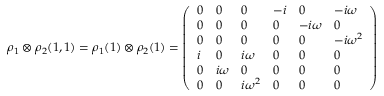Convert formula to latex. <formula><loc_0><loc_0><loc_500><loc_500>\rho _ { 1 } \otimes \rho _ { 2 } ( 1 , 1 ) = \rho _ { 1 } ( 1 ) \otimes \rho _ { 2 } ( 1 ) = { \left ( \begin{array} { l l l l l l } { 0 } & { 0 } & { 0 } & { - i } & { 0 } & { - i \omega } \\ { 0 } & { 0 } & { 0 } & { 0 } & { - i \omega } & { 0 } \\ { 0 } & { 0 } & { 0 } & { 0 } & { 0 } & { - i \omega ^ { 2 } } \\ { i } & { 0 } & { i \omega } & { 0 } & { 0 } & { 0 } \\ { 0 } & { i \omega } & { 0 } & { 0 } & { 0 } & { 0 } \\ { 0 } & { 0 } & { i \omega ^ { 2 } } & { 0 } & { 0 } & { 0 } \end{array} \right ) }</formula> 